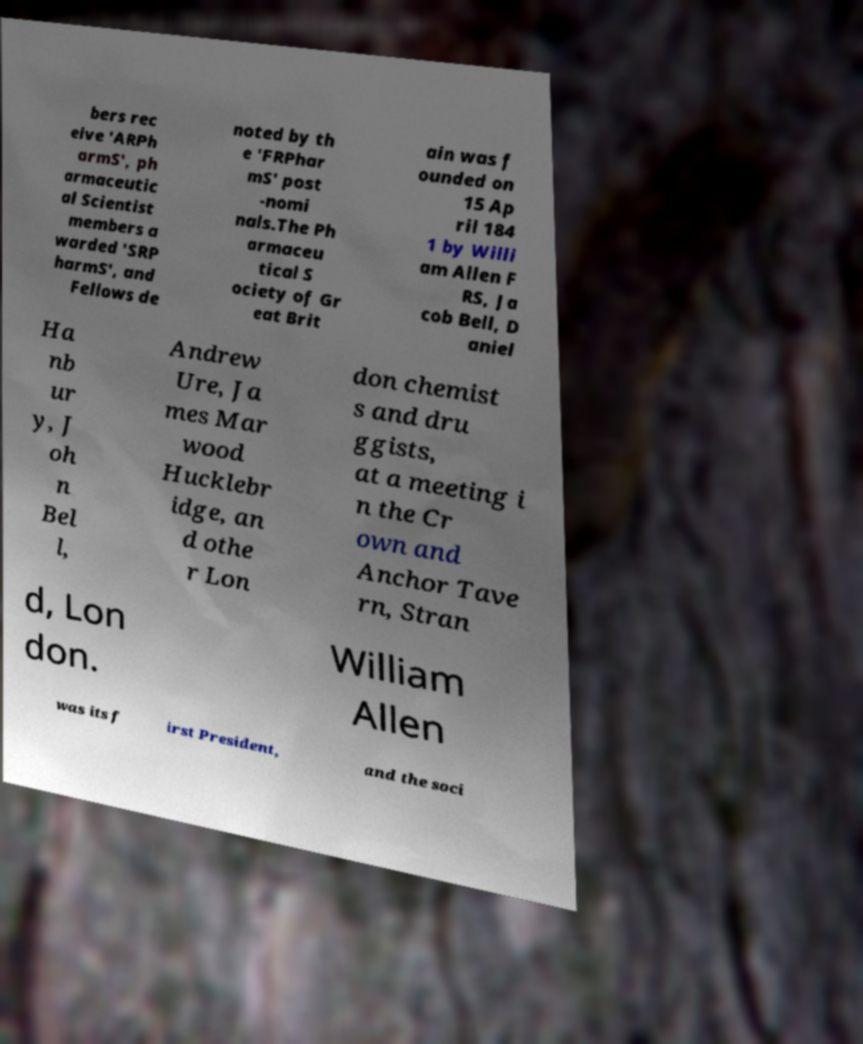Please read and relay the text visible in this image. What does it say? bers rec eive 'ARPh armS', ph armaceutic al Scientist members a warded 'SRP harmS', and Fellows de noted by th e 'FRPhar mS' post -nomi nals.The Ph armaceu tical S ociety of Gr eat Brit ain was f ounded on 15 Ap ril 184 1 by Willi am Allen F RS, Ja cob Bell, D aniel Ha nb ur y, J oh n Bel l, Andrew Ure, Ja mes Mar wood Hucklebr idge, an d othe r Lon don chemist s and dru ggists, at a meeting i n the Cr own and Anchor Tave rn, Stran d, Lon don. William Allen was its f irst President, and the soci 